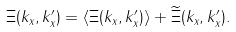Convert formula to latex. <formula><loc_0><loc_0><loc_500><loc_500>\Xi ( k _ { x } , k ^ { \prime } _ { x } ) = \langle \Xi ( k _ { x } , k ^ { \prime } _ { x } ) \rangle + \widetilde { \Xi } ( k _ { x } , k ^ { \prime } _ { x } ) .</formula> 